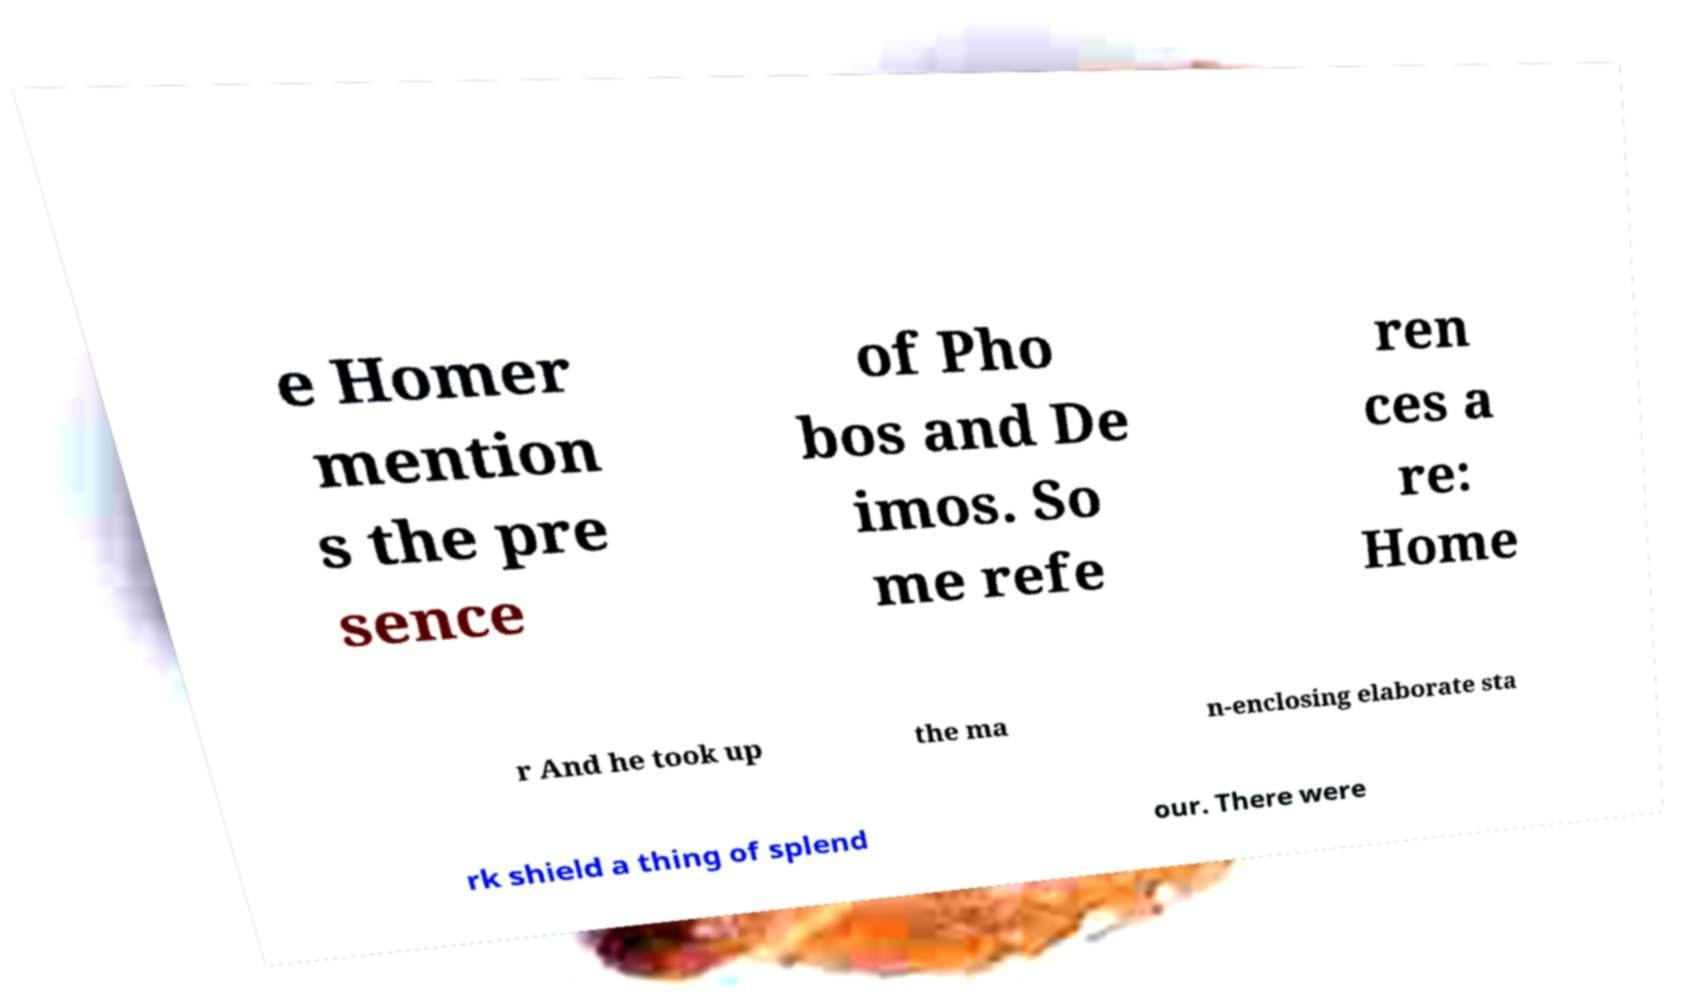Could you extract and type out the text from this image? e Homer mention s the pre sence of Pho bos and De imos. So me refe ren ces a re: Home r And he took up the ma n-enclosing elaborate sta rk shield a thing of splend our. There were 